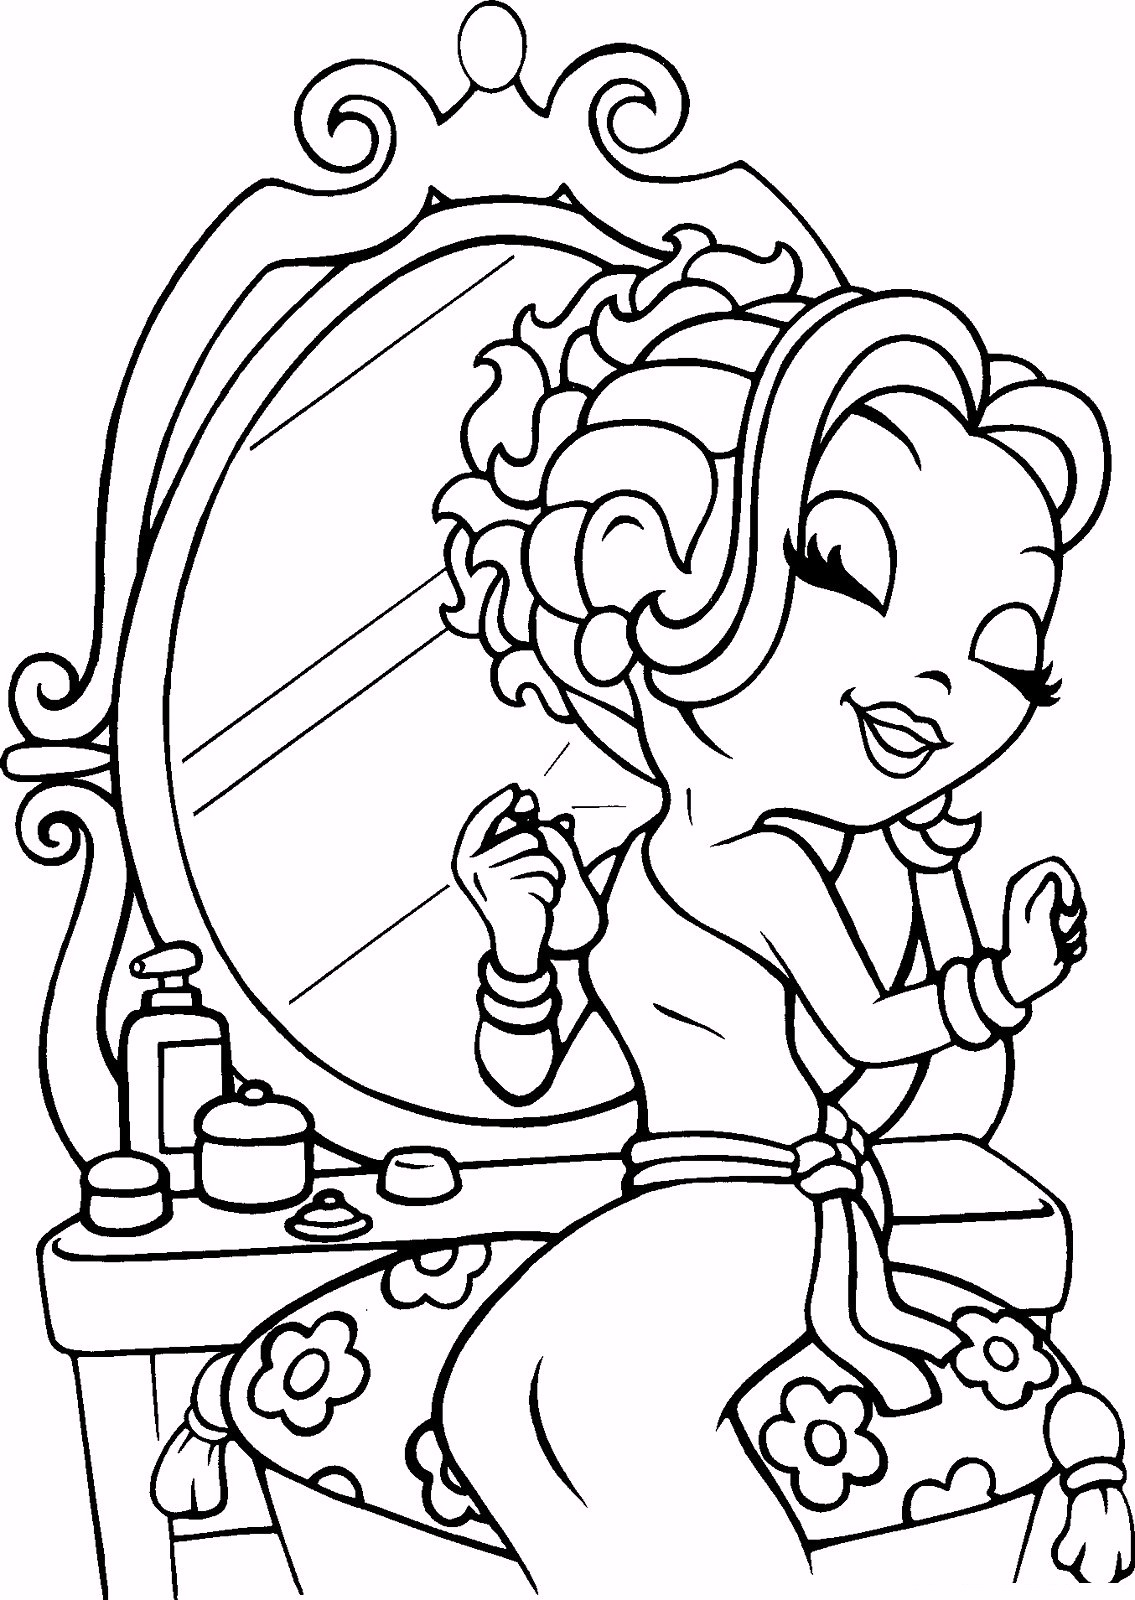Given the items on the table and the activity the girl is engaged in, what might be the purpose of the smaller container with a lid, and how does it relate to the overall setting and activity depicted in the image? The smaller container with a lid on the table in front of the girl is most likely for cosmetic or nail care supplies, such as cotton balls for cleaning nails or a small jar of cuticle cream. This container plays a role in the overall setting by complementing the girl's personal grooming routine. Surrounded by beauty products and clearly in the process of painting her nails, the image suggests a comprehensive approach to nail care that includes cleaning, moisturizing, and then applying nail polish. Every item on the table, including the smaller container, contributes to a detailed scene of self-care and beauty. 